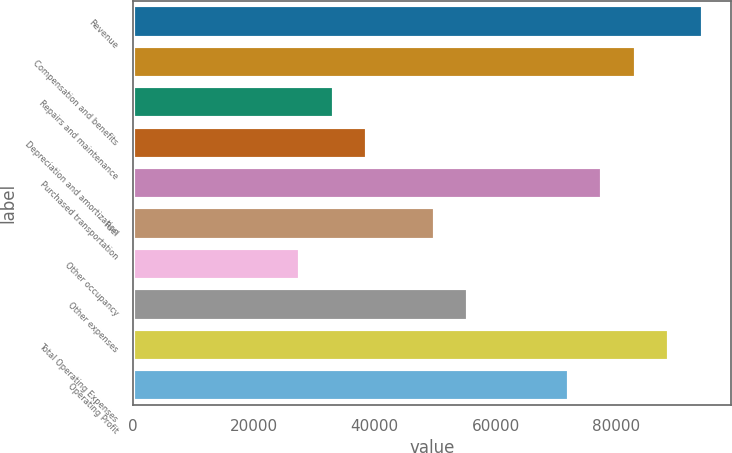Convert chart. <chart><loc_0><loc_0><loc_500><loc_500><bar_chart><fcel>Revenue<fcel>Compensation and benefits<fcel>Repairs and maintenance<fcel>Depreciation and amortization<fcel>Purchased transportation<fcel>Fuel<fcel>Other occupancy<fcel>Other expenses<fcel>Total Operating Expenses<fcel>Operating Profit<nl><fcel>94241.4<fcel>83154.7<fcel>33264.7<fcel>38808<fcel>77611.4<fcel>49894.7<fcel>27721.3<fcel>55438<fcel>88698.1<fcel>72068<nl></chart> 